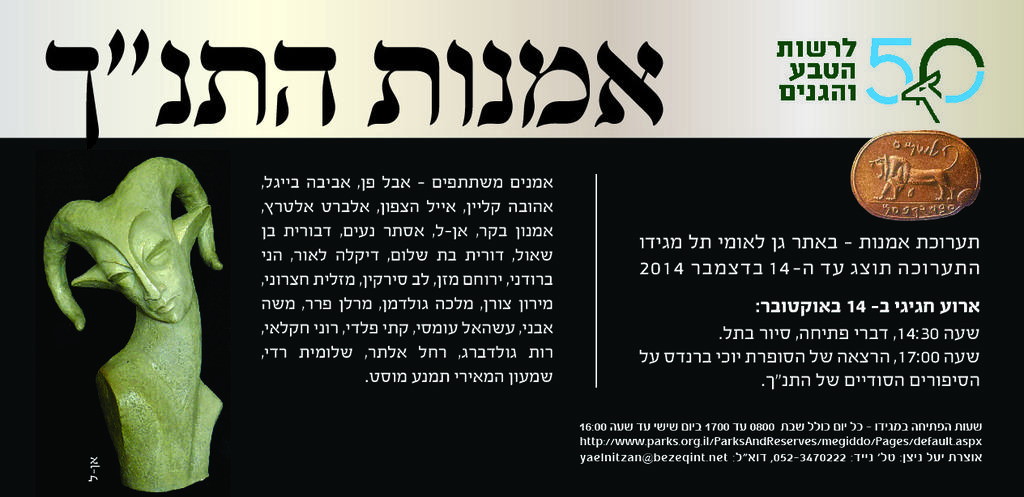What is depicted on the poster in the image? The poster contains a sculpture and a coin. Are there any words on the poster? Yes, the poster contains text. What is the primary subject of the poster? The primary subject of the poster is a sculpture. How many mice can be seen running along the river in the image? There are no mice or rivers present in the image; it features a poster with a sculpture, coin, and text. 